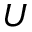Convert formula to latex. <formula><loc_0><loc_0><loc_500><loc_500>U</formula> 